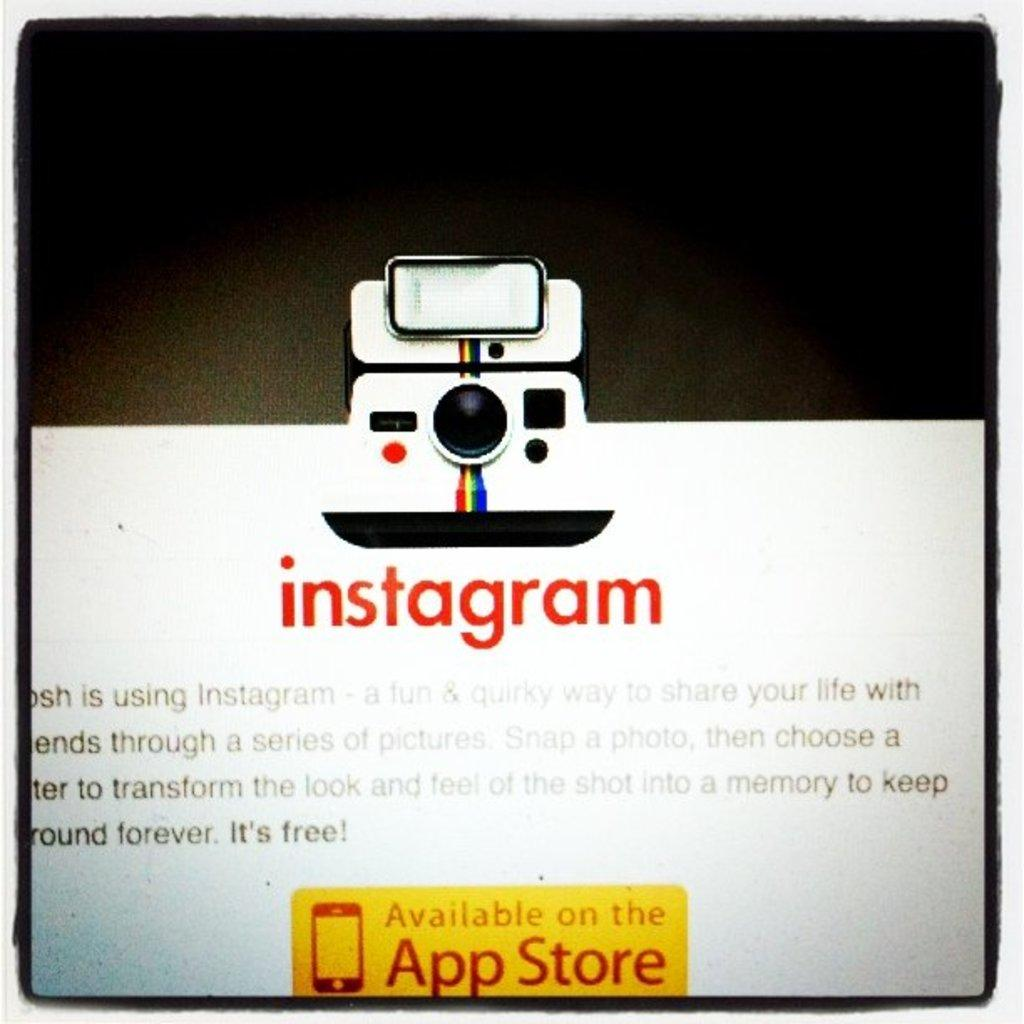What is present in the image that contains information or a message? There is a poster in the image that contains text. What else can be seen on the poster besides the text? There is an object depicted on the poster. What type of trip is being advertised on the poster in the image? There is no trip being advertised on the poster in the image; it only contains text and an object. How many letters are visible on the poster in the image? It is not possible to determine the exact number of letters on the poster in the image without more information. 